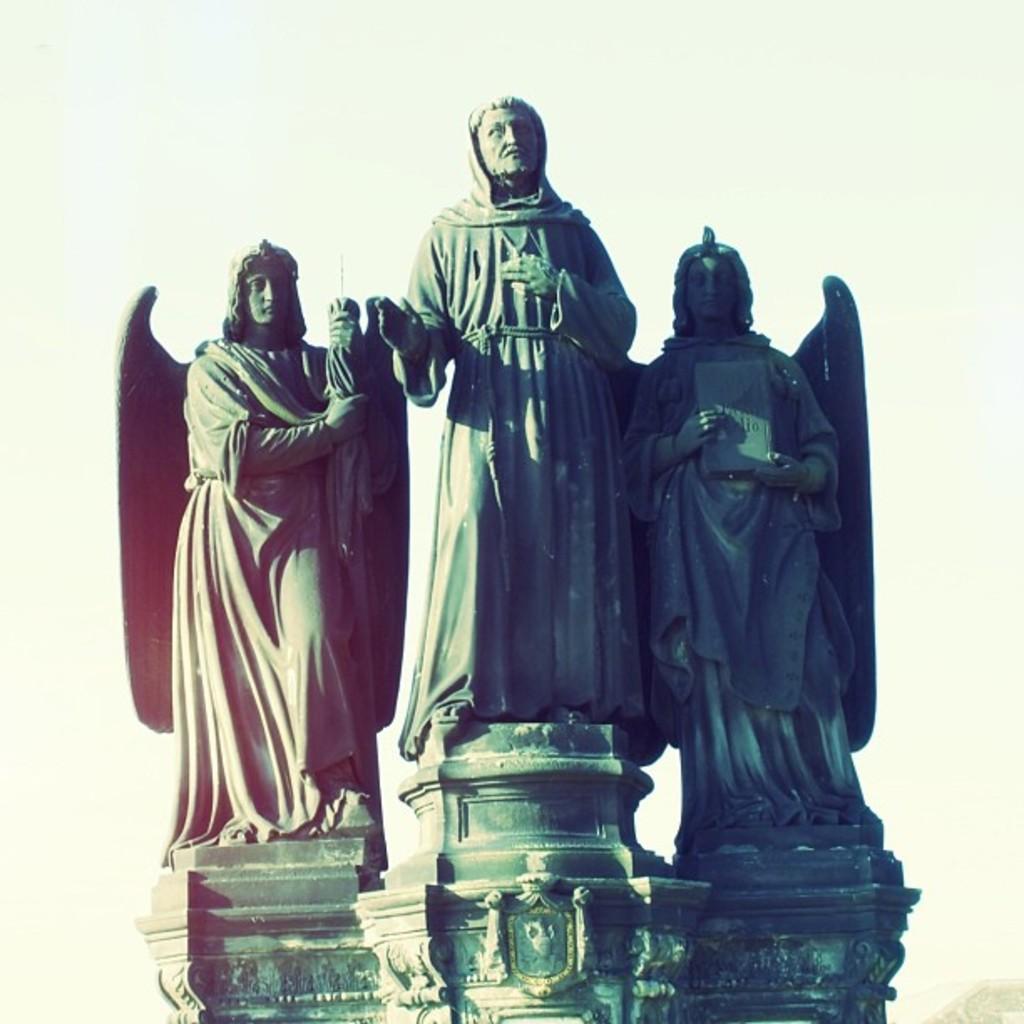Describe this image in one or two sentences. In the picture I can see the statue of a three persons standing which is in the black color and the background of the image is plain. 